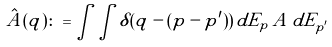Convert formula to latex. <formula><loc_0><loc_0><loc_500><loc_500>\hat { A } ( q ) \colon = \int \int \delta ( q - ( p - p ^ { \prime } ) ) \, d E _ { p } \, A \, d E _ { p ^ { \prime } }</formula> 